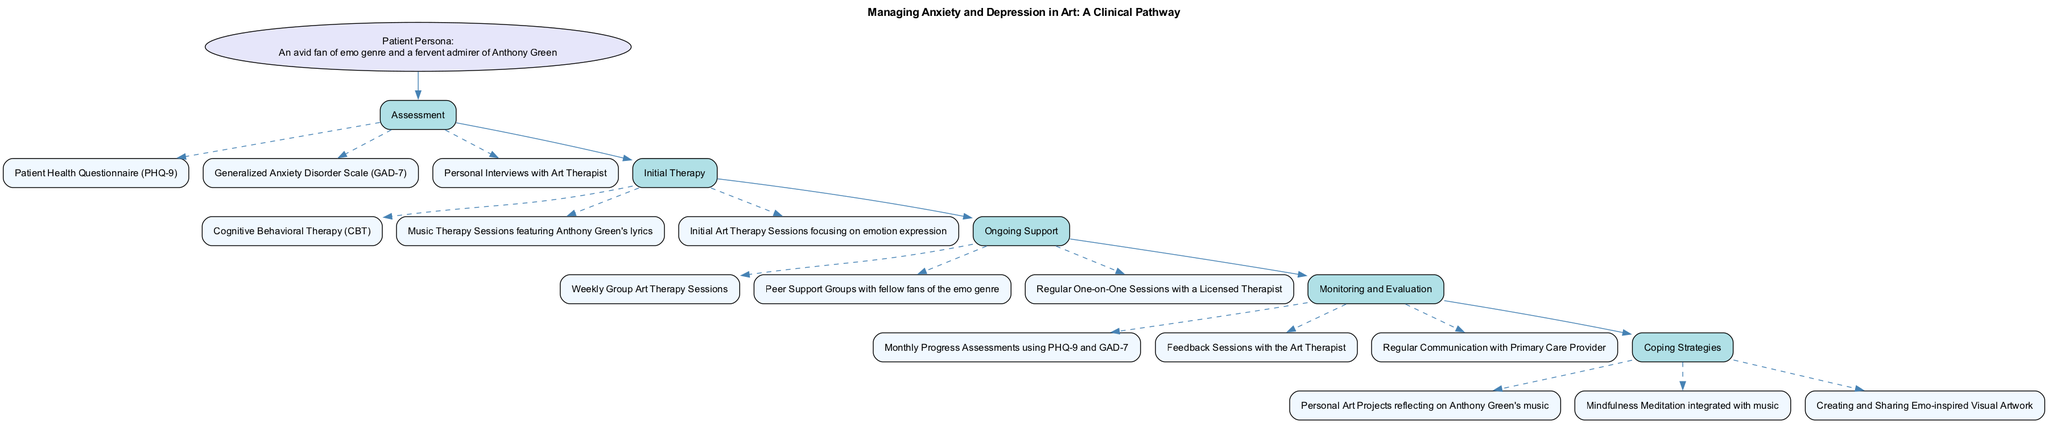What is the title of the clinical pathway? The title is found at the top of the diagram, clearly stating the focus of the pathway as "Managing Anxiety and Depression in Art: A Clinical Pathway."
Answer: Managing Anxiety and Depression in Art: A Clinical Pathway How many pathway stages are present? The pathway stages are listed in order from "Assessment" to "Coping Strategies." Counting each stage, there are five total stages.
Answer: 5 What is the first element in Initial Therapy? Looking under the "Initial Therapy" stage, the first element appears directly after the stage name, which is "Cognitive Behavioral Therapy (CBT)."
Answer: Cognitive Behavioral Therapy (CBT) Which therapy involves Anthony Green's lyrics? Within the "Initial Therapy" stage, the element referring to Anthony Green directly follows the mention of music therapy, indicating that these lyrics are used in the context of music therapy sessions.
Answer: Music Therapy Sessions featuring Anthony Green's lyrics How many elements are listed in Ongoing Support? In the "Ongoing Support" stage, there are three elements listed: "Weekly Group Art Therapy Sessions," "Peer Support Groups with fellow fans of the emo genre," and "Regular One-on-One Sessions with a Licensed Therapist." Counting these, there are three elements.
Answer: 3 What connects the Assessment stage to Initial Therapy? The connection between these two stages is represented by a directed edge, which visually shows the flow and progression from "Assessment" to "Initial Therapy." This indicates that the assessment stage leads directly into the initial therapy stage.
Answer: Edge Which stage comes after Monitoring and Evaluation? Following the "Monitoring and Evaluation" stage, the next stage displayed in the pathway is "Coping Strategies," which is the final step in the clinical pathway.
Answer: Coping Strategies What is the focus of personal art projects in Coping Strategies? The element mentions "Personal Art Projects reflecting on Anthony Green's music," thereby focusing on the emotional expression and connection through art inspired by his music.
Answer: Anthony Green's music What is the purpose of the Patient Health Questionnaire (PHQ-9)? The PHQ-9 is utilized during the "Assessment" stage as a tool to measure the severity of depression symptoms in the patient, establishing a baseline for diagnosis and follow-up.
Answer: Measure Depression Severity 